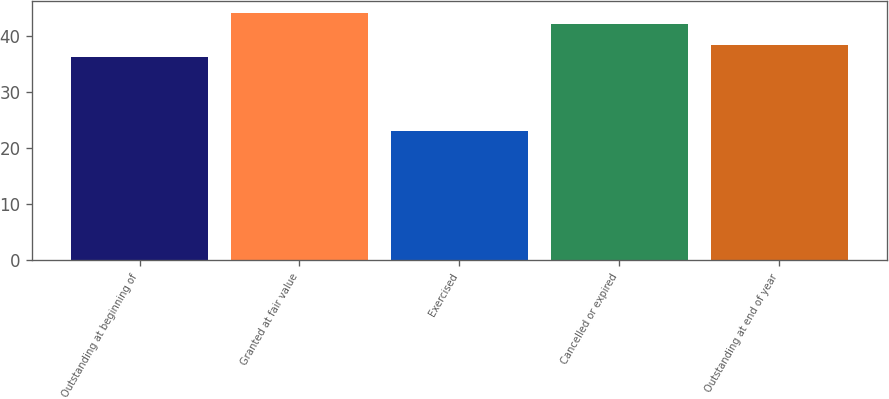Convert chart to OTSL. <chart><loc_0><loc_0><loc_500><loc_500><bar_chart><fcel>Outstanding at beginning of<fcel>Granted at fair value<fcel>Exercised<fcel>Cancelled or expired<fcel>Outstanding at end of year<nl><fcel>36.23<fcel>44.1<fcel>23.05<fcel>42.07<fcel>38.42<nl></chart> 